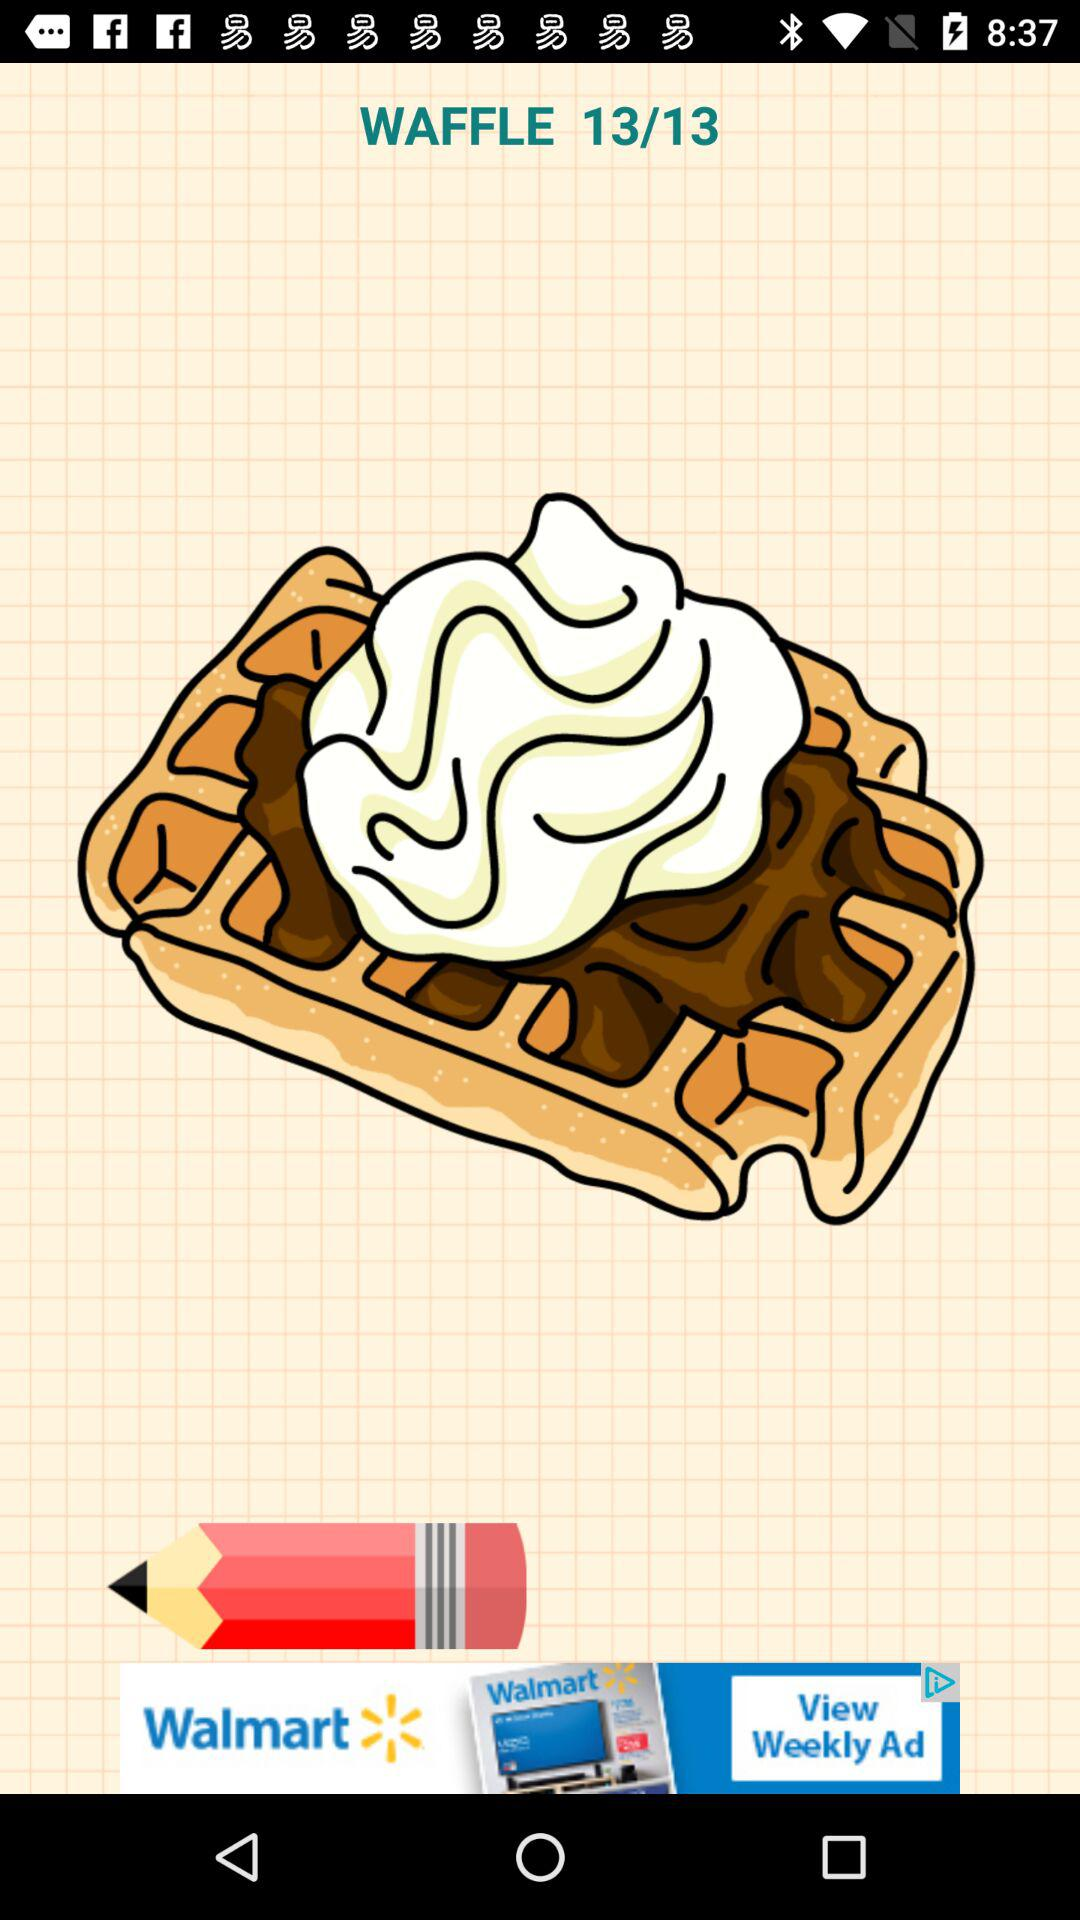I am on what page? You are on page number 13. 